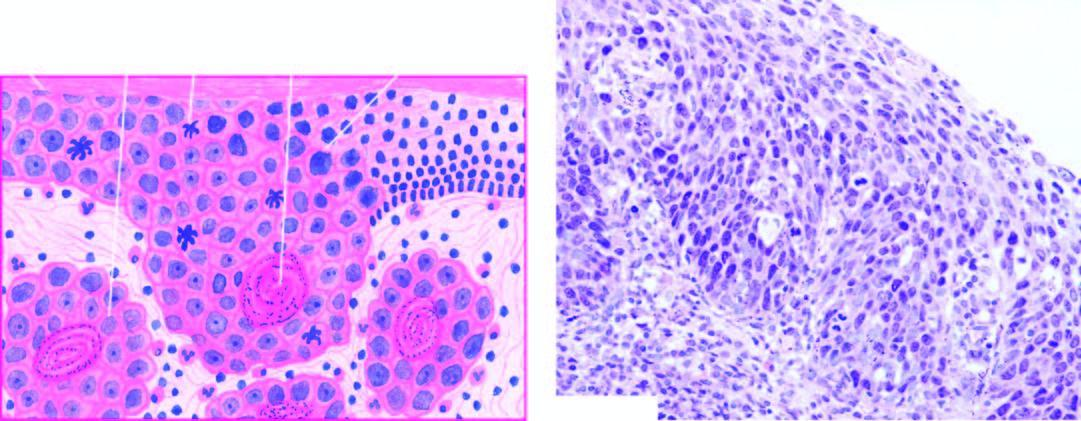do a few areas show superficial invasive islands of malignant cells in the subepithelial soft tissues?
Answer the question using a single word or phrase. Yes 